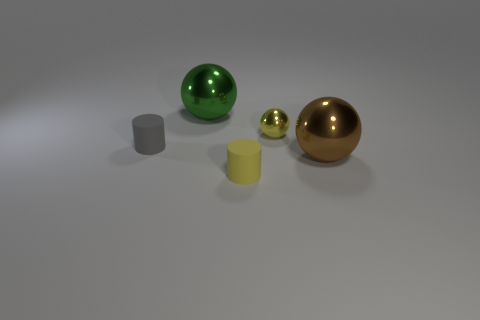Is there a big brown ball that has the same material as the green sphere?
Make the answer very short. Yes. There is a cylinder that is to the right of the big object that is behind the tiny gray thing; what is its material?
Make the answer very short. Rubber. Are there an equal number of objects that are in front of the gray matte thing and big objects on the right side of the tiny metal thing?
Make the answer very short. No. Is the yellow metallic object the same shape as the brown metallic thing?
Give a very brief answer. Yes. There is a object that is both on the right side of the small gray rubber cylinder and left of the small yellow rubber object; what material is it?
Your answer should be compact. Metal. How many other metallic things have the same shape as the large brown object?
Your answer should be compact. 2. There is a rubber cylinder that is on the left side of the large shiny object that is on the left side of the tiny yellow thing that is left of the tiny shiny sphere; how big is it?
Offer a very short reply. Small. Is the number of large green shiny spheres that are on the right side of the tiny yellow rubber thing greater than the number of big blue things?
Offer a terse response. No. Are there any cyan metal cylinders?
Offer a terse response. No. What number of red cylinders have the same size as the brown metal ball?
Ensure brevity in your answer.  0. 